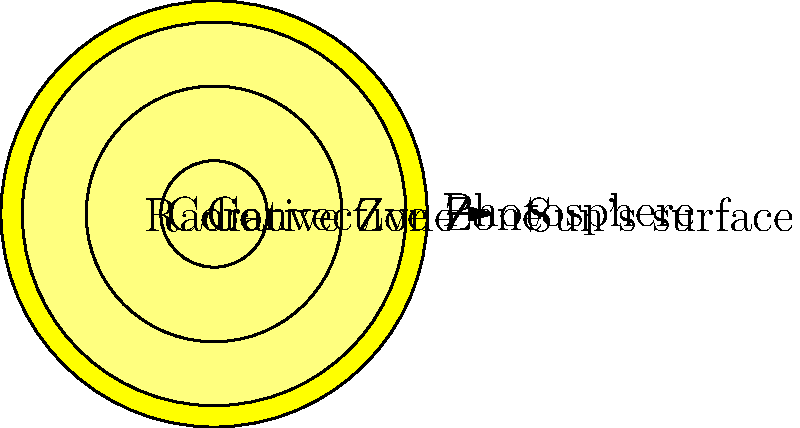In the cross-section of the Sun shown above, which layer would be most akin to the intricate harmonies in a traditional Scottish reel, where energy is transferred through complex interactions? To answer this question, let's break down the layers of the Sun and their characteristics:

1. Core: This is the central region where nuclear fusion occurs, generating the Sun's energy. It's like the heart of the melody in a Scottish folk tune.

2. Radiative Zone: In this layer, energy is transferred outward through radiation. Photons bounce around in a complex pattern, similar to the way notes interact in a harmonious piece.

3. Convective Zone: Here, energy is transferred through the rising and falling of hot and cool plasma. This movement is reminiscent of the ebb and flow in a traditional Scottish reel.

4. Photosphere: This is the visible surface of the Sun, where the energy finally escapes into space.

The question asks which layer is most like the intricate harmonies in a Scottish reel. The Radiative Zone best fits this description because:

1. It involves complex interactions of photons, similar to the interplay of notes in a harmony.
2. The energy transfer is not straightforward but involves numerous collisions and redirections, much like the intricate patterns in a traditional reel.
3. The process in the Radiative Zone takes thousands of years, similar to how traditional music evolves over time while maintaining its core structure.

Therefore, the Radiative Zone is the most fitting answer to this question.
Answer: Radiative Zone 